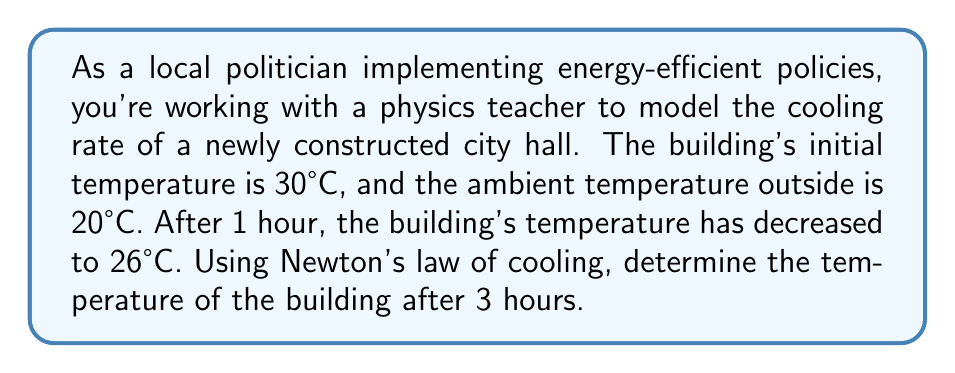Can you answer this question? To solve this problem, we'll use Newton's law of cooling, which is expressed as a differential equation:

$$\frac{dT}{dt} = -k(T - T_a)$$

Where:
- $T$ is the temperature of the building
- $T_a$ is the ambient temperature
- $k$ is the cooling constant
- $t$ is time

Step 1: Solve the differential equation
The solution to this equation is:
$$T(t) = T_a + (T_0 - T_a)e^{-kt}$$
Where $T_0$ is the initial temperature.

Step 2: Determine the cooling constant $k$
We know:
- $T_0 = 30°C$
- $T_a = 20°C$
- After 1 hour $(t=1)$, $T = 26°C$

Substituting these values into our solution:
$$26 = 20 + (30 - 20)e^{-k(1)}$$
$$6 = 10e^{-k}$$
$$\ln(0.6) = -k$$
$$k = -\ln(0.6) \approx 0.5108$$

Step 3: Use the solution to find the temperature after 3 hours
Now we can use our solution with $t=3$:
$$T(3) = 20 + (30 - 20)e^{-0.5108(3)}$$
$$T(3) = 20 + 10e^{-1.5324}$$
$$T(3) = 20 + 10(0.2161)$$
$$T(3) = 22.161°C$$
Answer: The temperature of the building after 3 hours will be approximately 22.2°C. 